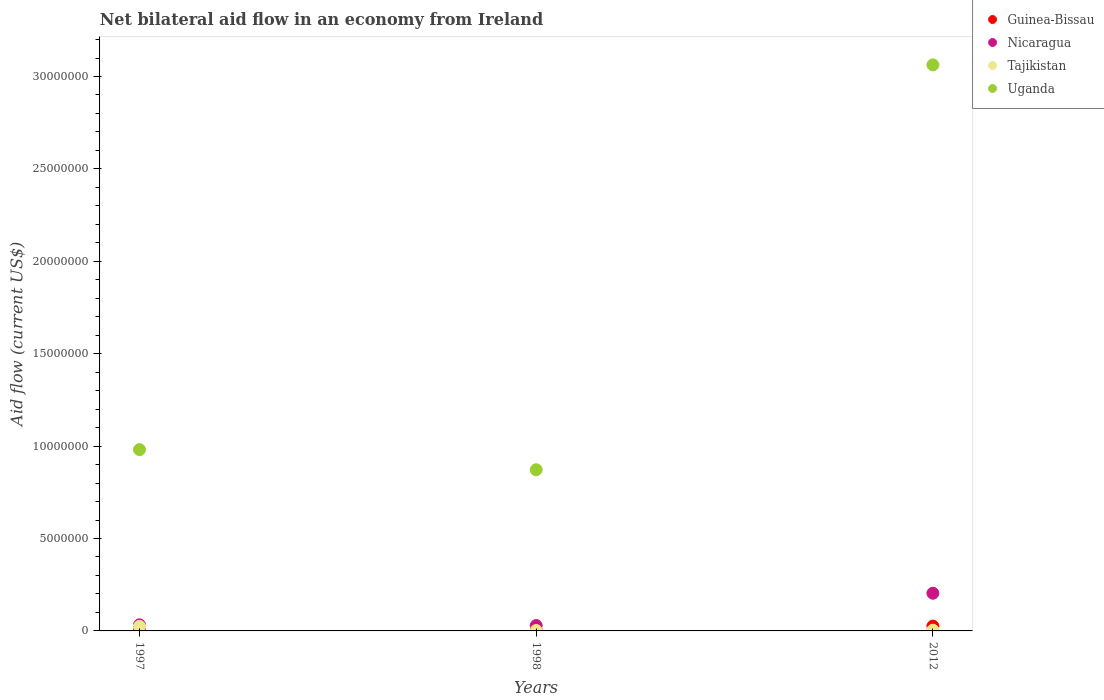Is the number of dotlines equal to the number of legend labels?
Provide a short and direct response. Yes. Across all years, what is the maximum net bilateral aid flow in Nicaragua?
Offer a terse response. 2.04e+06. Across all years, what is the minimum net bilateral aid flow in Tajikistan?
Your response must be concise. 2.00e+04. What is the total net bilateral aid flow in Nicaragua in the graph?
Ensure brevity in your answer.  2.66e+06. What is the difference between the net bilateral aid flow in Guinea-Bissau in 1997 and that in 1998?
Offer a terse response. 0. What is the difference between the net bilateral aid flow in Nicaragua in 1998 and the net bilateral aid flow in Tajikistan in 2012?
Provide a succinct answer. 2.50e+05. What is the average net bilateral aid flow in Nicaragua per year?
Provide a short and direct response. 8.87e+05. In the year 1997, what is the difference between the net bilateral aid flow in Nicaragua and net bilateral aid flow in Uganda?
Ensure brevity in your answer.  -9.48e+06. What is the ratio of the net bilateral aid flow in Nicaragua in 1997 to that in 2012?
Provide a succinct answer. 0.16. Is the difference between the net bilateral aid flow in Nicaragua in 1997 and 2012 greater than the difference between the net bilateral aid flow in Uganda in 1997 and 2012?
Your answer should be compact. Yes. What is the difference between the highest and the second highest net bilateral aid flow in Uganda?
Your answer should be compact. 2.08e+07. What is the difference between the highest and the lowest net bilateral aid flow in Nicaragua?
Provide a short and direct response. 1.75e+06. Is the sum of the net bilateral aid flow in Tajikistan in 1998 and 2012 greater than the maximum net bilateral aid flow in Uganda across all years?
Your answer should be very brief. No. How many dotlines are there?
Ensure brevity in your answer.  4. How many years are there in the graph?
Give a very brief answer. 3. Are the values on the major ticks of Y-axis written in scientific E-notation?
Keep it short and to the point. No. Does the graph contain any zero values?
Your answer should be compact. No. Does the graph contain grids?
Keep it short and to the point. No. How many legend labels are there?
Offer a very short reply. 4. How are the legend labels stacked?
Offer a very short reply. Vertical. What is the title of the graph?
Your answer should be very brief. Net bilateral aid flow in an economy from Ireland. Does "Cabo Verde" appear as one of the legend labels in the graph?
Offer a terse response. No. What is the label or title of the X-axis?
Provide a short and direct response. Years. What is the label or title of the Y-axis?
Your response must be concise. Aid flow (current US$). What is the Aid flow (current US$) in Guinea-Bissau in 1997?
Your response must be concise. 2.00e+04. What is the Aid flow (current US$) in Nicaragua in 1997?
Provide a succinct answer. 3.30e+05. What is the Aid flow (current US$) in Uganda in 1997?
Ensure brevity in your answer.  9.81e+06. What is the Aid flow (current US$) in Guinea-Bissau in 1998?
Provide a succinct answer. 2.00e+04. What is the Aid flow (current US$) in Nicaragua in 1998?
Make the answer very short. 2.90e+05. What is the Aid flow (current US$) in Uganda in 1998?
Your response must be concise. 8.72e+06. What is the Aid flow (current US$) of Nicaragua in 2012?
Ensure brevity in your answer.  2.04e+06. What is the Aid flow (current US$) of Tajikistan in 2012?
Make the answer very short. 4.00e+04. What is the Aid flow (current US$) in Uganda in 2012?
Provide a succinct answer. 3.06e+07. Across all years, what is the maximum Aid flow (current US$) of Guinea-Bissau?
Make the answer very short. 2.60e+05. Across all years, what is the maximum Aid flow (current US$) in Nicaragua?
Your response must be concise. 2.04e+06. Across all years, what is the maximum Aid flow (current US$) of Tajikistan?
Make the answer very short. 2.50e+05. Across all years, what is the maximum Aid flow (current US$) in Uganda?
Offer a terse response. 3.06e+07. Across all years, what is the minimum Aid flow (current US$) in Uganda?
Your response must be concise. 8.72e+06. What is the total Aid flow (current US$) of Guinea-Bissau in the graph?
Give a very brief answer. 3.00e+05. What is the total Aid flow (current US$) of Nicaragua in the graph?
Your answer should be very brief. 2.66e+06. What is the total Aid flow (current US$) of Uganda in the graph?
Keep it short and to the point. 4.92e+07. What is the difference between the Aid flow (current US$) of Guinea-Bissau in 1997 and that in 1998?
Offer a terse response. 0. What is the difference between the Aid flow (current US$) in Uganda in 1997 and that in 1998?
Your response must be concise. 1.09e+06. What is the difference between the Aid flow (current US$) in Guinea-Bissau in 1997 and that in 2012?
Your answer should be compact. -2.40e+05. What is the difference between the Aid flow (current US$) of Nicaragua in 1997 and that in 2012?
Offer a terse response. -1.71e+06. What is the difference between the Aid flow (current US$) of Tajikistan in 1997 and that in 2012?
Your answer should be very brief. 2.10e+05. What is the difference between the Aid flow (current US$) of Uganda in 1997 and that in 2012?
Your answer should be very brief. -2.08e+07. What is the difference between the Aid flow (current US$) in Nicaragua in 1998 and that in 2012?
Provide a short and direct response. -1.75e+06. What is the difference between the Aid flow (current US$) in Tajikistan in 1998 and that in 2012?
Offer a terse response. -2.00e+04. What is the difference between the Aid flow (current US$) in Uganda in 1998 and that in 2012?
Make the answer very short. -2.19e+07. What is the difference between the Aid flow (current US$) of Guinea-Bissau in 1997 and the Aid flow (current US$) of Uganda in 1998?
Provide a short and direct response. -8.70e+06. What is the difference between the Aid flow (current US$) in Nicaragua in 1997 and the Aid flow (current US$) in Uganda in 1998?
Offer a terse response. -8.39e+06. What is the difference between the Aid flow (current US$) of Tajikistan in 1997 and the Aid flow (current US$) of Uganda in 1998?
Keep it short and to the point. -8.47e+06. What is the difference between the Aid flow (current US$) of Guinea-Bissau in 1997 and the Aid flow (current US$) of Nicaragua in 2012?
Keep it short and to the point. -2.02e+06. What is the difference between the Aid flow (current US$) of Guinea-Bissau in 1997 and the Aid flow (current US$) of Uganda in 2012?
Provide a short and direct response. -3.06e+07. What is the difference between the Aid flow (current US$) of Nicaragua in 1997 and the Aid flow (current US$) of Uganda in 2012?
Provide a short and direct response. -3.03e+07. What is the difference between the Aid flow (current US$) in Tajikistan in 1997 and the Aid flow (current US$) in Uganda in 2012?
Ensure brevity in your answer.  -3.04e+07. What is the difference between the Aid flow (current US$) of Guinea-Bissau in 1998 and the Aid flow (current US$) of Nicaragua in 2012?
Keep it short and to the point. -2.02e+06. What is the difference between the Aid flow (current US$) in Guinea-Bissau in 1998 and the Aid flow (current US$) in Uganda in 2012?
Keep it short and to the point. -3.06e+07. What is the difference between the Aid flow (current US$) in Nicaragua in 1998 and the Aid flow (current US$) in Tajikistan in 2012?
Ensure brevity in your answer.  2.50e+05. What is the difference between the Aid flow (current US$) in Nicaragua in 1998 and the Aid flow (current US$) in Uganda in 2012?
Offer a terse response. -3.03e+07. What is the difference between the Aid flow (current US$) of Tajikistan in 1998 and the Aid flow (current US$) of Uganda in 2012?
Your response must be concise. -3.06e+07. What is the average Aid flow (current US$) of Guinea-Bissau per year?
Provide a short and direct response. 1.00e+05. What is the average Aid flow (current US$) of Nicaragua per year?
Give a very brief answer. 8.87e+05. What is the average Aid flow (current US$) in Tajikistan per year?
Your answer should be very brief. 1.03e+05. What is the average Aid flow (current US$) in Uganda per year?
Offer a very short reply. 1.64e+07. In the year 1997, what is the difference between the Aid flow (current US$) in Guinea-Bissau and Aid flow (current US$) in Nicaragua?
Ensure brevity in your answer.  -3.10e+05. In the year 1997, what is the difference between the Aid flow (current US$) of Guinea-Bissau and Aid flow (current US$) of Uganda?
Ensure brevity in your answer.  -9.79e+06. In the year 1997, what is the difference between the Aid flow (current US$) in Nicaragua and Aid flow (current US$) in Uganda?
Make the answer very short. -9.48e+06. In the year 1997, what is the difference between the Aid flow (current US$) in Tajikistan and Aid flow (current US$) in Uganda?
Ensure brevity in your answer.  -9.56e+06. In the year 1998, what is the difference between the Aid flow (current US$) of Guinea-Bissau and Aid flow (current US$) of Nicaragua?
Provide a succinct answer. -2.70e+05. In the year 1998, what is the difference between the Aid flow (current US$) in Guinea-Bissau and Aid flow (current US$) in Uganda?
Your response must be concise. -8.70e+06. In the year 1998, what is the difference between the Aid flow (current US$) in Nicaragua and Aid flow (current US$) in Tajikistan?
Provide a short and direct response. 2.70e+05. In the year 1998, what is the difference between the Aid flow (current US$) of Nicaragua and Aid flow (current US$) of Uganda?
Your answer should be very brief. -8.43e+06. In the year 1998, what is the difference between the Aid flow (current US$) in Tajikistan and Aid flow (current US$) in Uganda?
Offer a very short reply. -8.70e+06. In the year 2012, what is the difference between the Aid flow (current US$) in Guinea-Bissau and Aid flow (current US$) in Nicaragua?
Offer a terse response. -1.78e+06. In the year 2012, what is the difference between the Aid flow (current US$) in Guinea-Bissau and Aid flow (current US$) in Tajikistan?
Offer a very short reply. 2.20e+05. In the year 2012, what is the difference between the Aid flow (current US$) in Guinea-Bissau and Aid flow (current US$) in Uganda?
Offer a terse response. -3.04e+07. In the year 2012, what is the difference between the Aid flow (current US$) of Nicaragua and Aid flow (current US$) of Uganda?
Make the answer very short. -2.86e+07. In the year 2012, what is the difference between the Aid flow (current US$) in Tajikistan and Aid flow (current US$) in Uganda?
Give a very brief answer. -3.06e+07. What is the ratio of the Aid flow (current US$) of Guinea-Bissau in 1997 to that in 1998?
Give a very brief answer. 1. What is the ratio of the Aid flow (current US$) in Nicaragua in 1997 to that in 1998?
Your answer should be compact. 1.14. What is the ratio of the Aid flow (current US$) in Tajikistan in 1997 to that in 1998?
Give a very brief answer. 12.5. What is the ratio of the Aid flow (current US$) of Guinea-Bissau in 1997 to that in 2012?
Your answer should be compact. 0.08. What is the ratio of the Aid flow (current US$) in Nicaragua in 1997 to that in 2012?
Make the answer very short. 0.16. What is the ratio of the Aid flow (current US$) in Tajikistan in 1997 to that in 2012?
Keep it short and to the point. 6.25. What is the ratio of the Aid flow (current US$) of Uganda in 1997 to that in 2012?
Offer a terse response. 0.32. What is the ratio of the Aid flow (current US$) in Guinea-Bissau in 1998 to that in 2012?
Offer a very short reply. 0.08. What is the ratio of the Aid flow (current US$) of Nicaragua in 1998 to that in 2012?
Your answer should be very brief. 0.14. What is the ratio of the Aid flow (current US$) in Uganda in 1998 to that in 2012?
Your answer should be very brief. 0.28. What is the difference between the highest and the second highest Aid flow (current US$) of Guinea-Bissau?
Your answer should be very brief. 2.40e+05. What is the difference between the highest and the second highest Aid flow (current US$) in Nicaragua?
Keep it short and to the point. 1.71e+06. What is the difference between the highest and the second highest Aid flow (current US$) of Uganda?
Give a very brief answer. 2.08e+07. What is the difference between the highest and the lowest Aid flow (current US$) in Nicaragua?
Keep it short and to the point. 1.75e+06. What is the difference between the highest and the lowest Aid flow (current US$) in Uganda?
Your answer should be compact. 2.19e+07. 